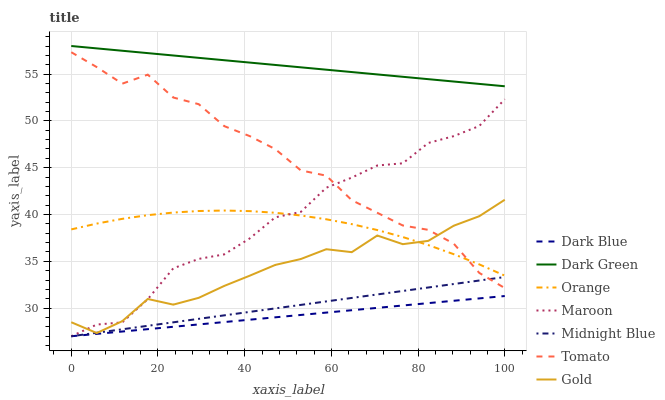Does Dark Blue have the minimum area under the curve?
Answer yes or no. Yes. Does Dark Green have the maximum area under the curve?
Answer yes or no. Yes. Does Midnight Blue have the minimum area under the curve?
Answer yes or no. No. Does Midnight Blue have the maximum area under the curve?
Answer yes or no. No. Is Dark Blue the smoothest?
Answer yes or no. Yes. Is Tomato the roughest?
Answer yes or no. Yes. Is Midnight Blue the smoothest?
Answer yes or no. No. Is Midnight Blue the roughest?
Answer yes or no. No. Does Midnight Blue have the lowest value?
Answer yes or no. Yes. Does Gold have the lowest value?
Answer yes or no. No. Does Dark Green have the highest value?
Answer yes or no. Yes. Does Midnight Blue have the highest value?
Answer yes or no. No. Is Dark Blue less than Orange?
Answer yes or no. Yes. Is Dark Green greater than Midnight Blue?
Answer yes or no. Yes. Does Midnight Blue intersect Tomato?
Answer yes or no. Yes. Is Midnight Blue less than Tomato?
Answer yes or no. No. Is Midnight Blue greater than Tomato?
Answer yes or no. No. Does Dark Blue intersect Orange?
Answer yes or no. No. 